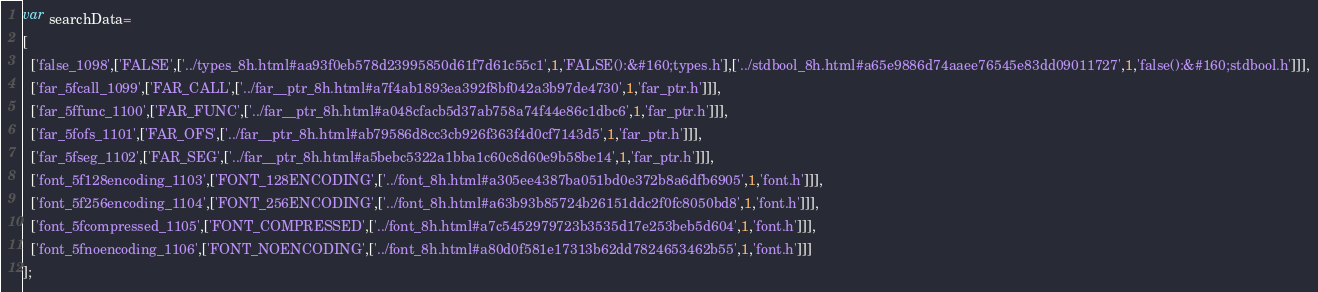Convert code to text. <code><loc_0><loc_0><loc_500><loc_500><_JavaScript_>var searchData=
[
  ['false_1098',['FALSE',['../types_8h.html#aa93f0eb578d23995850d61f7d61c55c1',1,'FALSE():&#160;types.h'],['../stdbool_8h.html#a65e9886d74aaee76545e83dd09011727',1,'false():&#160;stdbool.h']]],
  ['far_5fcall_1099',['FAR_CALL',['../far__ptr_8h.html#a7f4ab1893ea392f8bf042a3b97de4730',1,'far_ptr.h']]],
  ['far_5ffunc_1100',['FAR_FUNC',['../far__ptr_8h.html#a048cfacb5d37ab758a74f44e86c1dbc6',1,'far_ptr.h']]],
  ['far_5fofs_1101',['FAR_OFS',['../far__ptr_8h.html#ab79586d8cc3cb926f363f4d0cf7143d5',1,'far_ptr.h']]],
  ['far_5fseg_1102',['FAR_SEG',['../far__ptr_8h.html#a5bebc5322a1bba1c60c8d60e9b58be14',1,'far_ptr.h']]],
  ['font_5f128encoding_1103',['FONT_128ENCODING',['../font_8h.html#a305ee4387ba051bd0e372b8a6dfb6905',1,'font.h']]],
  ['font_5f256encoding_1104',['FONT_256ENCODING',['../font_8h.html#a63b93b85724b26151ddc2f0fc8050bd8',1,'font.h']]],
  ['font_5fcompressed_1105',['FONT_COMPRESSED',['../font_8h.html#a7c5452979723b3535d17e253beb5d604',1,'font.h']]],
  ['font_5fnoencoding_1106',['FONT_NOENCODING',['../font_8h.html#a80d0f581e17313b62dd7824653462b55',1,'font.h']]]
];
</code> 